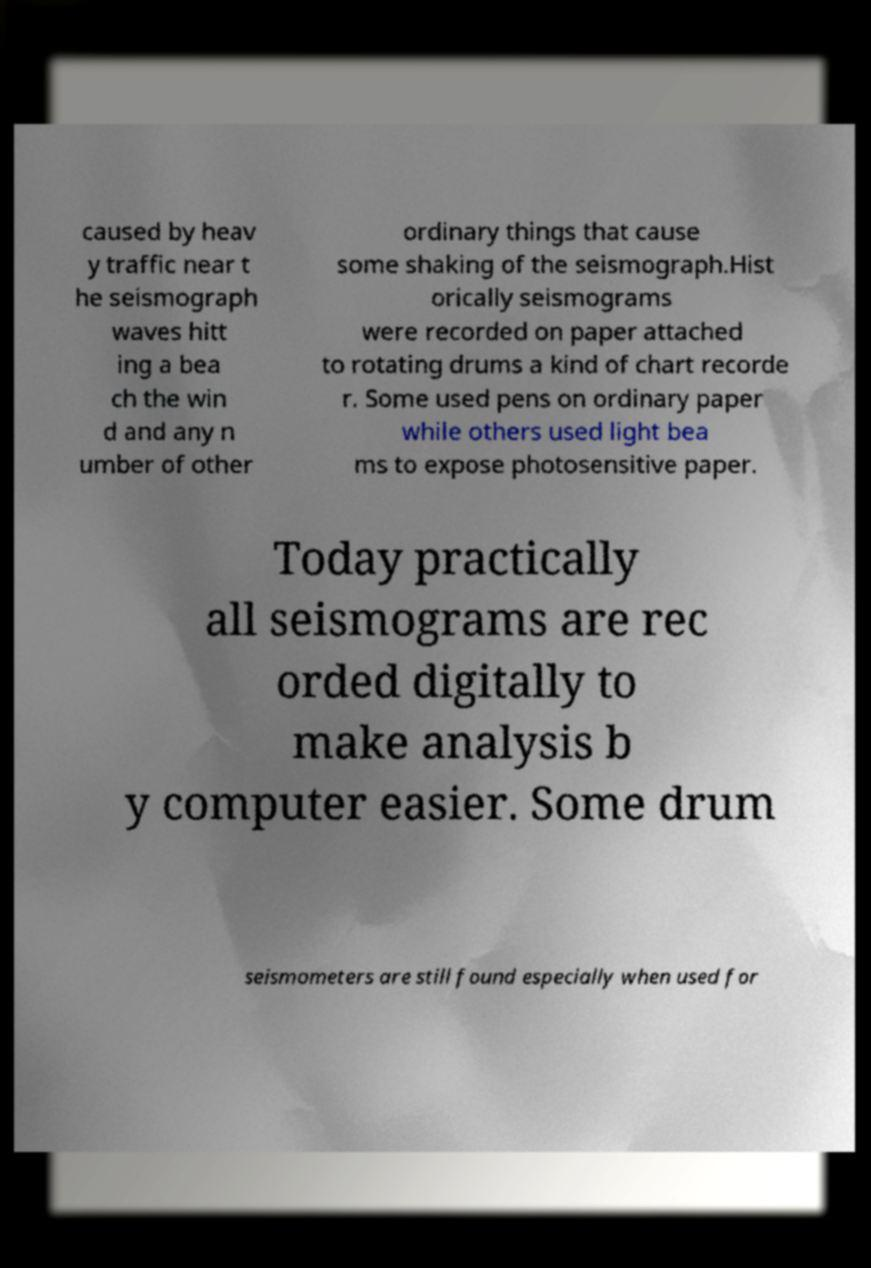Please read and relay the text visible in this image. What does it say? caused by heav y traffic near t he seismograph waves hitt ing a bea ch the win d and any n umber of other ordinary things that cause some shaking of the seismograph.Hist orically seismograms were recorded on paper attached to rotating drums a kind of chart recorde r. Some used pens on ordinary paper while others used light bea ms to expose photosensitive paper. Today practically all seismograms are rec orded digitally to make analysis b y computer easier. Some drum seismometers are still found especially when used for 